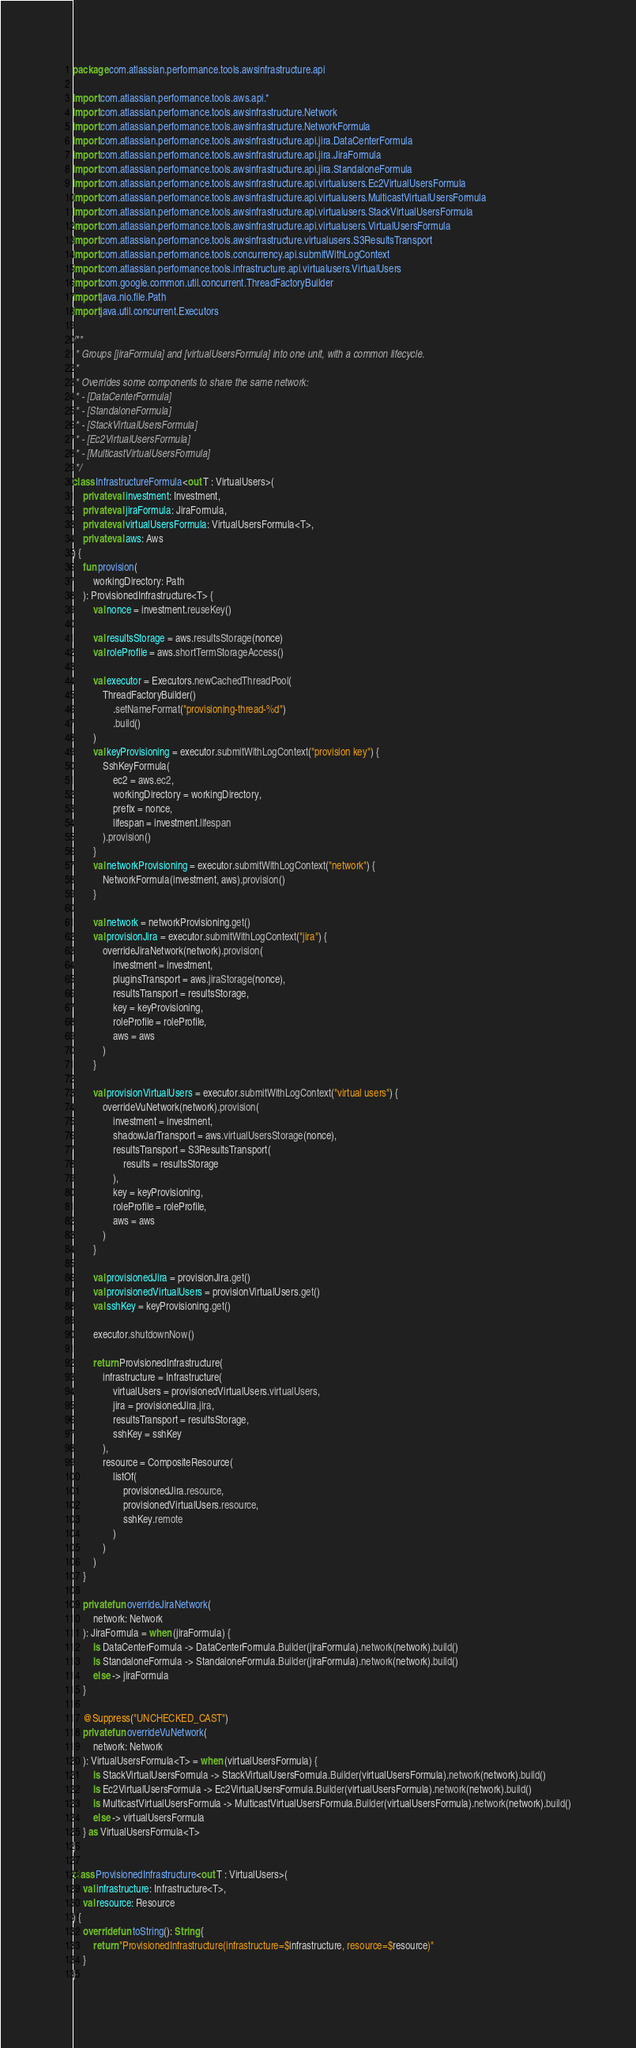Convert code to text. <code><loc_0><loc_0><loc_500><loc_500><_Kotlin_>package com.atlassian.performance.tools.awsinfrastructure.api

import com.atlassian.performance.tools.aws.api.*
import com.atlassian.performance.tools.awsinfrastructure.Network
import com.atlassian.performance.tools.awsinfrastructure.NetworkFormula
import com.atlassian.performance.tools.awsinfrastructure.api.jira.DataCenterFormula
import com.atlassian.performance.tools.awsinfrastructure.api.jira.JiraFormula
import com.atlassian.performance.tools.awsinfrastructure.api.jira.StandaloneFormula
import com.atlassian.performance.tools.awsinfrastructure.api.virtualusers.Ec2VirtualUsersFormula
import com.atlassian.performance.tools.awsinfrastructure.api.virtualusers.MulticastVirtualUsersFormula
import com.atlassian.performance.tools.awsinfrastructure.api.virtualusers.StackVirtualUsersFormula
import com.atlassian.performance.tools.awsinfrastructure.api.virtualusers.VirtualUsersFormula
import com.atlassian.performance.tools.awsinfrastructure.virtualusers.S3ResultsTransport
import com.atlassian.performance.tools.concurrency.api.submitWithLogContext
import com.atlassian.performance.tools.infrastructure.api.virtualusers.VirtualUsers
import com.google.common.util.concurrent.ThreadFactoryBuilder
import java.nio.file.Path
import java.util.concurrent.Executors

/**
 * Groups [jiraFormula] and [virtualUsersFormula] into one unit, with a common lifecycle.
 *
 * Overrides some components to share the same network:
 * - [DataCenterFormula]
 * - [StandaloneFormula]
 * - [StackVirtualUsersFormula]
 * - [Ec2VirtualUsersFormula]
 * - [MulticastVirtualUsersFormula]
 */
class InfrastructureFormula<out T : VirtualUsers>(
    private val investment: Investment,
    private val jiraFormula: JiraFormula,
    private val virtualUsersFormula: VirtualUsersFormula<T>,
    private val aws: Aws
) {
    fun provision(
        workingDirectory: Path
    ): ProvisionedInfrastructure<T> {
        val nonce = investment.reuseKey()

        val resultsStorage = aws.resultsStorage(nonce)
        val roleProfile = aws.shortTermStorageAccess()

        val executor = Executors.newCachedThreadPool(
            ThreadFactoryBuilder()
                .setNameFormat("provisioning-thread-%d")
                .build()
        )
        val keyProvisioning = executor.submitWithLogContext("provision key") {
            SshKeyFormula(
                ec2 = aws.ec2,
                workingDirectory = workingDirectory,
                prefix = nonce,
                lifespan = investment.lifespan
            ).provision()
        }
        val networkProvisioning = executor.submitWithLogContext("network") {
            NetworkFormula(investment, aws).provision()
        }

        val network = networkProvisioning.get()
        val provisionJira = executor.submitWithLogContext("jira") {
            overrideJiraNetwork(network).provision(
                investment = investment,
                pluginsTransport = aws.jiraStorage(nonce),
                resultsTransport = resultsStorage,
                key = keyProvisioning,
                roleProfile = roleProfile,
                aws = aws
            )
        }

        val provisionVirtualUsers = executor.submitWithLogContext("virtual users") {
            overrideVuNetwork(network).provision(
                investment = investment,
                shadowJarTransport = aws.virtualUsersStorage(nonce),
                resultsTransport = S3ResultsTransport(
                    results = resultsStorage
                ),
                key = keyProvisioning,
                roleProfile = roleProfile,
                aws = aws
            )
        }

        val provisionedJira = provisionJira.get()
        val provisionedVirtualUsers = provisionVirtualUsers.get()
        val sshKey = keyProvisioning.get()

        executor.shutdownNow()

        return ProvisionedInfrastructure(
            infrastructure = Infrastructure(
                virtualUsers = provisionedVirtualUsers.virtualUsers,
                jira = provisionedJira.jira,
                resultsTransport = resultsStorage,
                sshKey = sshKey
            ),
            resource = CompositeResource(
                listOf(
                    provisionedJira.resource,
                    provisionedVirtualUsers.resource,
                    sshKey.remote
                )
            )
        )
    }

    private fun overrideJiraNetwork(
        network: Network
    ): JiraFormula = when (jiraFormula) {
        is DataCenterFormula -> DataCenterFormula.Builder(jiraFormula).network(network).build()
        is StandaloneFormula -> StandaloneFormula.Builder(jiraFormula).network(network).build()
        else -> jiraFormula
    }

    @Suppress("UNCHECKED_CAST")
    private fun overrideVuNetwork(
        network: Network
    ): VirtualUsersFormula<T> = when (virtualUsersFormula) {
        is StackVirtualUsersFormula -> StackVirtualUsersFormula.Builder(virtualUsersFormula).network(network).build()
        is Ec2VirtualUsersFormula -> Ec2VirtualUsersFormula.Builder(virtualUsersFormula).network(network).build()
        is MulticastVirtualUsersFormula -> MulticastVirtualUsersFormula.Builder(virtualUsersFormula).network(network).build()
        else -> virtualUsersFormula
    } as VirtualUsersFormula<T>
}

class ProvisionedInfrastructure<out T : VirtualUsers>(
    val infrastructure: Infrastructure<T>,
    val resource: Resource
) {
    override fun toString(): String {
        return "ProvisionedInfrastructure(infrastructure=$infrastructure, resource=$resource)"
    }
}</code> 